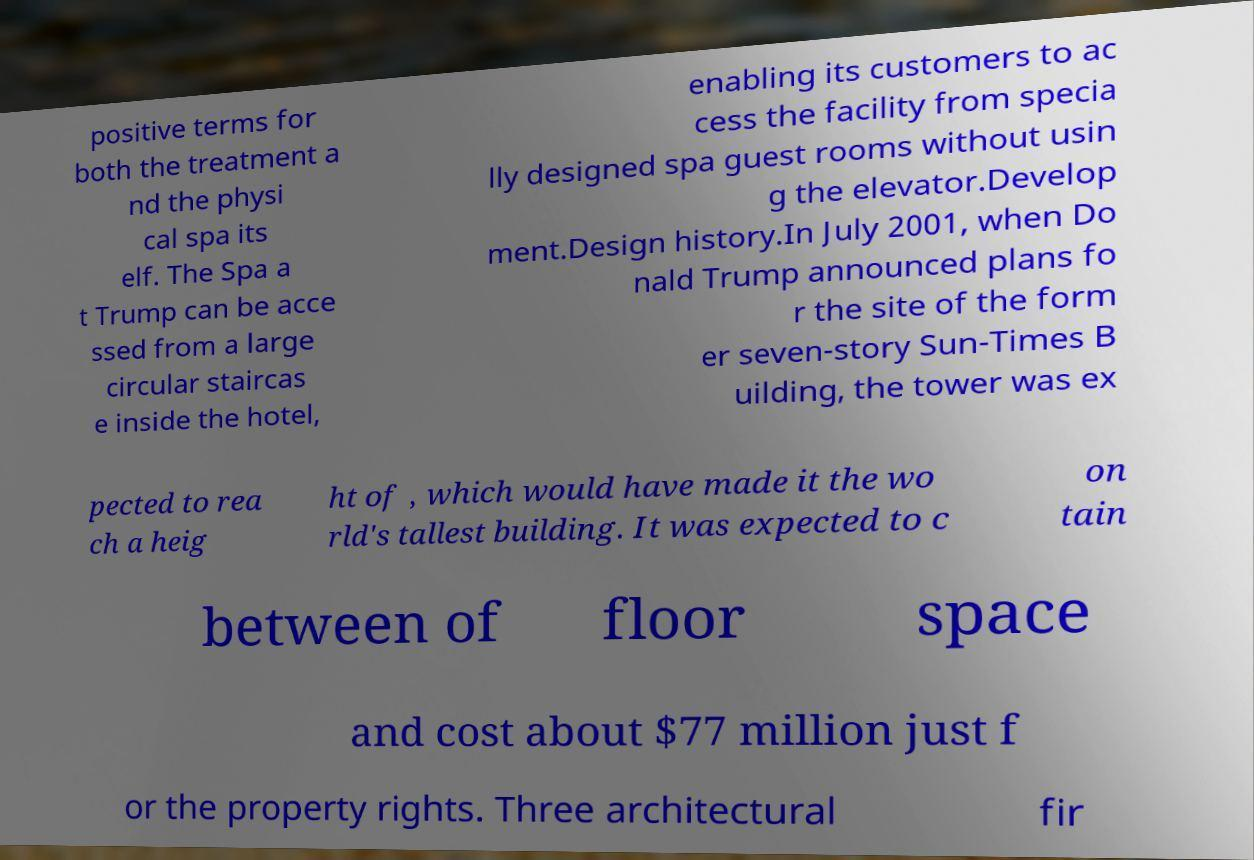Can you read and provide the text displayed in the image?This photo seems to have some interesting text. Can you extract and type it out for me? positive terms for both the treatment a nd the physi cal spa its elf. The Spa a t Trump can be acce ssed from a large circular staircas e inside the hotel, enabling its customers to ac cess the facility from specia lly designed spa guest rooms without usin g the elevator.Develop ment.Design history.In July 2001, when Do nald Trump announced plans fo r the site of the form er seven-story Sun-Times B uilding, the tower was ex pected to rea ch a heig ht of , which would have made it the wo rld's tallest building. It was expected to c on tain between of floor space and cost about $77 million just f or the property rights. Three architectural fir 